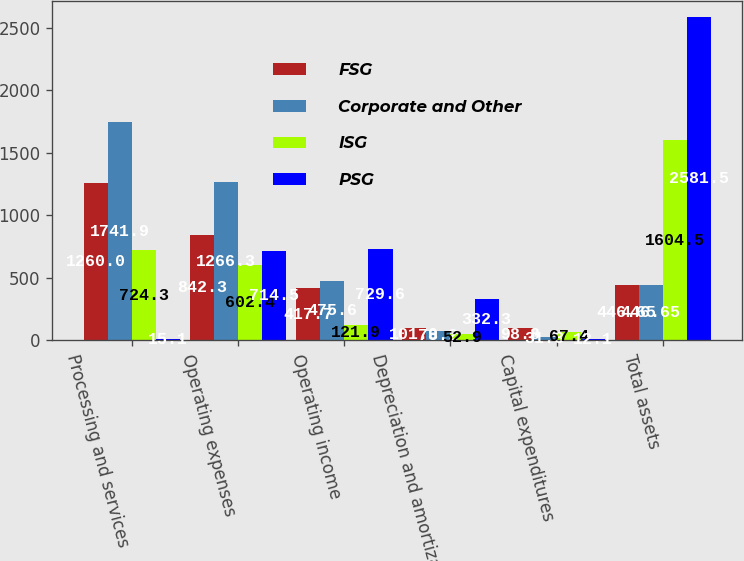<chart> <loc_0><loc_0><loc_500><loc_500><stacked_bar_chart><ecel><fcel>Processing and services<fcel>Operating expenses<fcel>Operating income<fcel>Depreciation and amortization<fcel>Capital expenditures<fcel>Total assets<nl><fcel>FSG<fcel>1260<fcel>842.3<fcel>417.7<fcel>101<fcel>98.8<fcel>446.65<nl><fcel>Corporate and Other<fcel>1741.9<fcel>1266.3<fcel>475.6<fcel>78.2<fcel>31.3<fcel>446.65<nl><fcel>ISG<fcel>724.3<fcel>602.4<fcel>121.9<fcel>52.9<fcel>67.4<fcel>1604.5<nl><fcel>PSG<fcel>15.1<fcel>714.5<fcel>729.6<fcel>332.3<fcel>12.1<fcel>2581.5<nl></chart> 